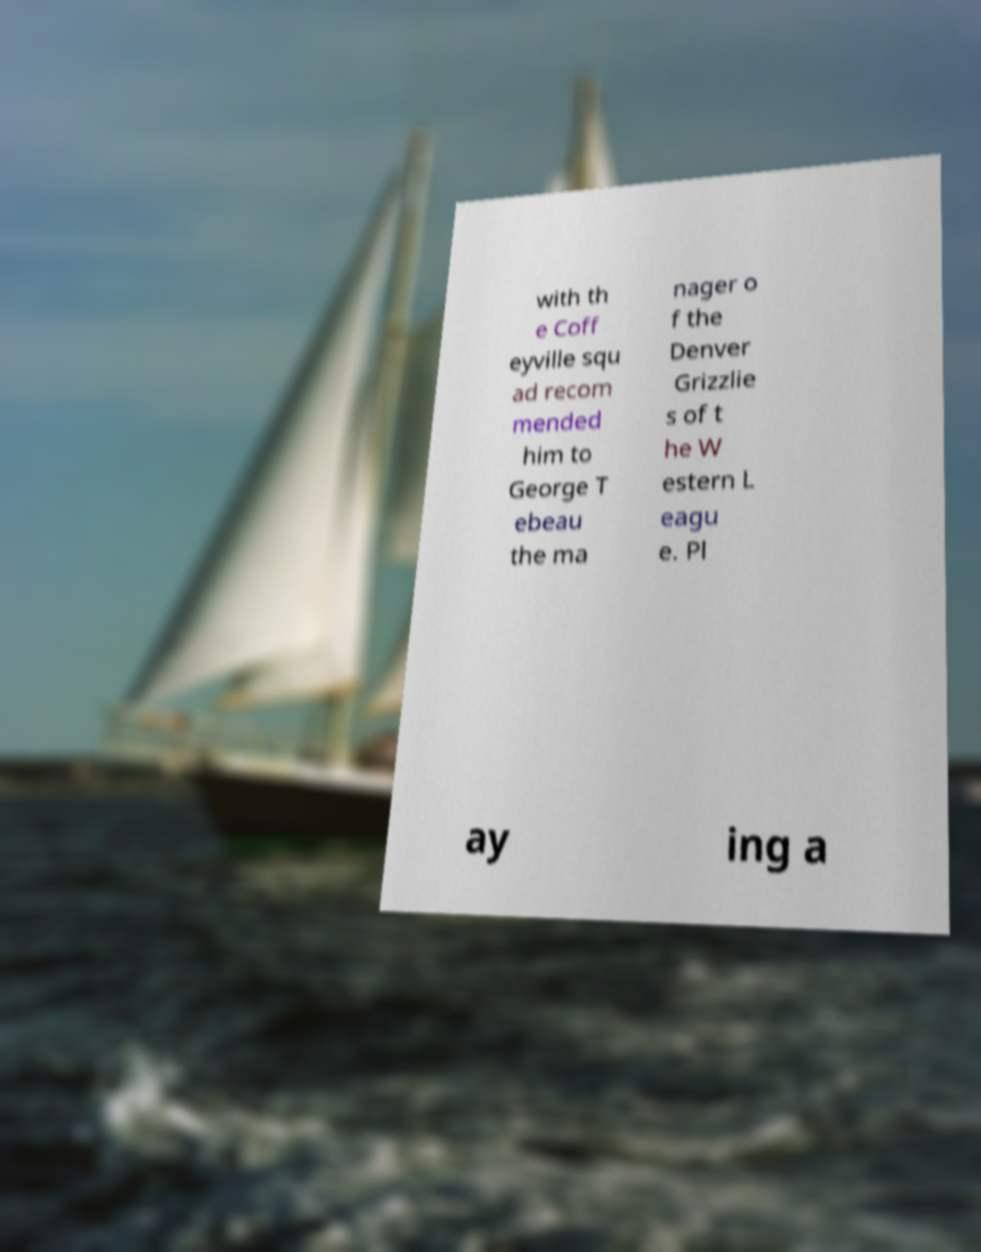Please read and relay the text visible in this image. What does it say? with th e Coff eyville squ ad recom mended him to George T ebeau the ma nager o f the Denver Grizzlie s of t he W estern L eagu e. Pl ay ing a 